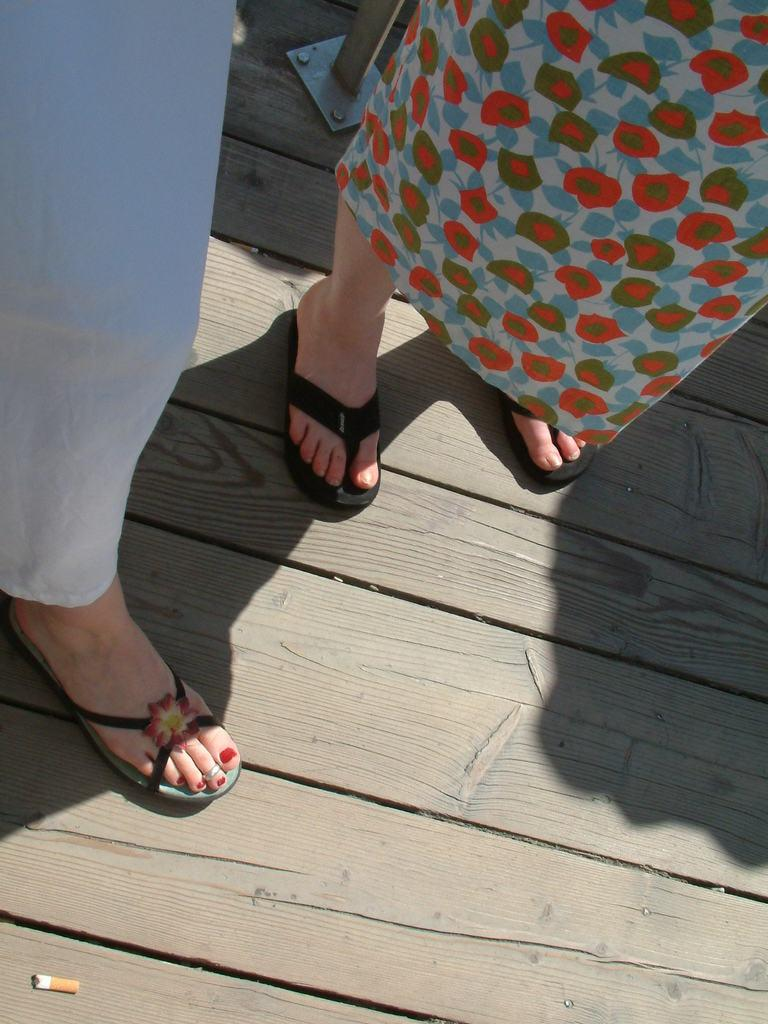What is the main subject of the image? The main subject of the image is two human legs with footwears. What type of flooring is visible in the image? The legs are on a wooden floor. Are there any other objects visible in the image? Yes, there is a cigarette at the bottom of the image and an iron stand at the top of the image. Can you provide an example of a family member in the image? There is no family member present in the image. 